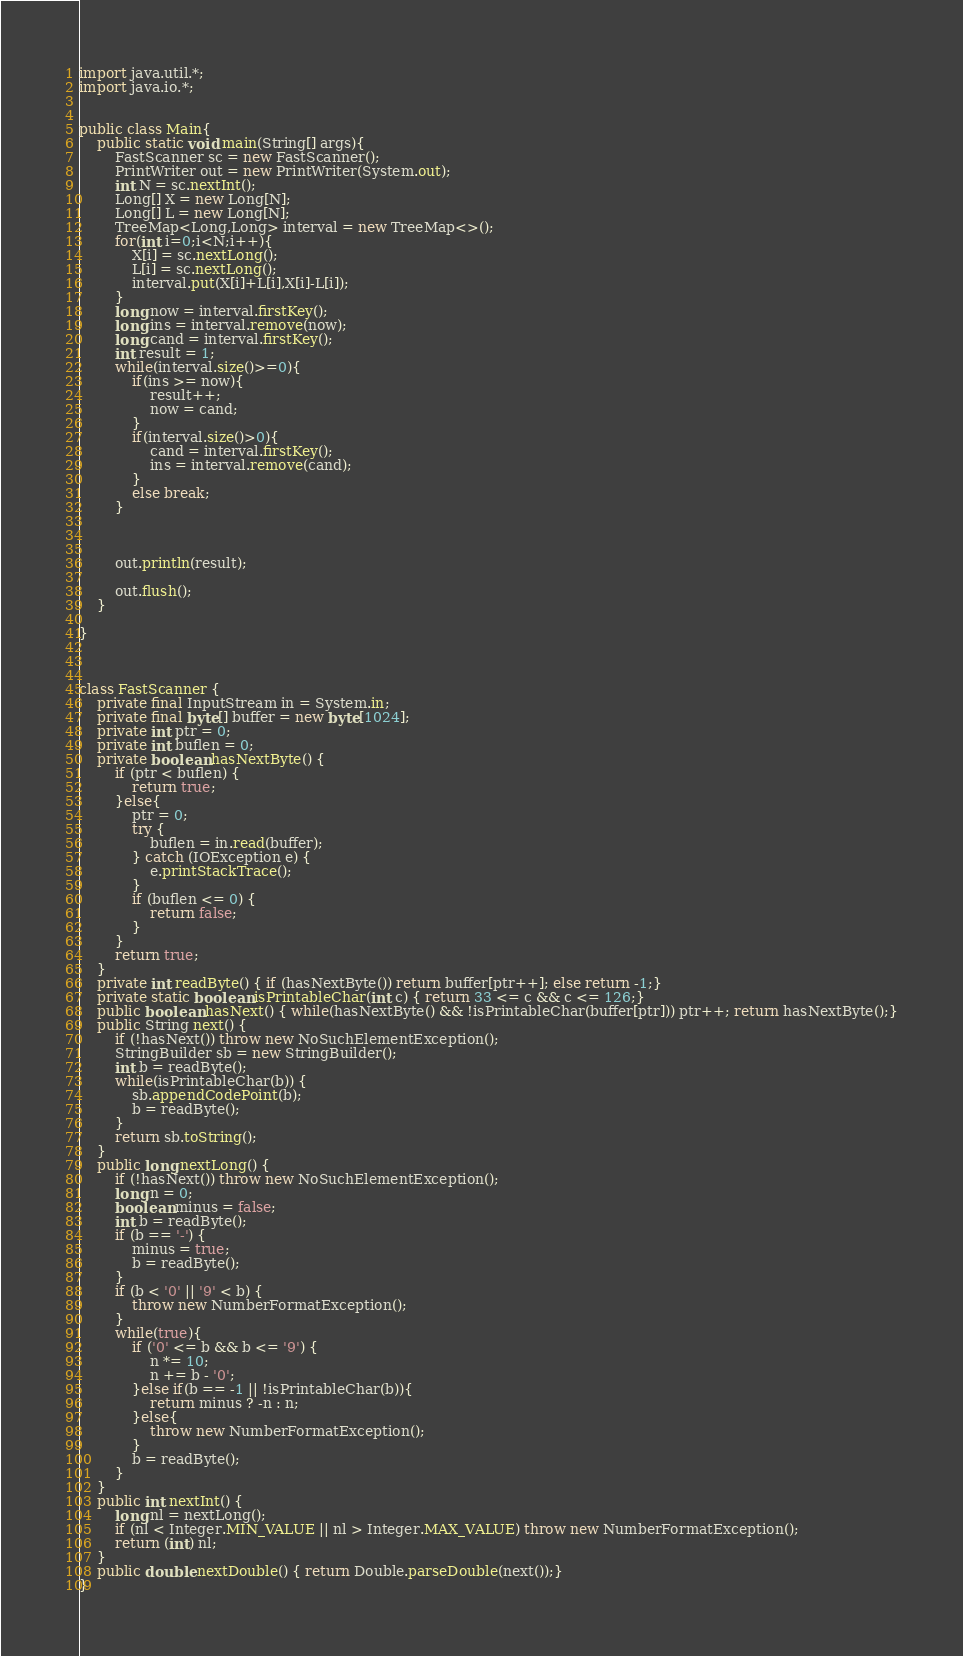<code> <loc_0><loc_0><loc_500><loc_500><_Java_>import java.util.*;
import java.io.*;


public class Main{
    public static void main(String[] args){
        FastScanner sc = new FastScanner();
        PrintWriter out = new PrintWriter(System.out);
        int N = sc.nextInt();
        Long[] X = new Long[N];
        Long[] L = new Long[N];
        TreeMap<Long,Long> interval = new TreeMap<>();
        for(int i=0;i<N;i++){
            X[i] = sc.nextLong();
            L[i] = sc.nextLong();
            interval.put(X[i]+L[i],X[i]-L[i]);
        }
        long now = interval.firstKey();
        long ins = interval.remove(now);
        long cand = interval.firstKey();
        int result = 1;
        while(interval.size()>=0){
            if(ins >= now){
                result++;
                now = cand;
            }
            if(interval.size()>0){
                cand = interval.firstKey();
                ins = interval.remove(cand);
            }
            else break;
        }



        out.println(result);

        out.flush();
    }
        
}



class FastScanner {
    private final InputStream in = System.in;
    private final byte[] buffer = new byte[1024];
    private int ptr = 0;
    private int buflen = 0;
    private boolean hasNextByte() {
        if (ptr < buflen) {
            return true;
        }else{
            ptr = 0;
            try {
                buflen = in.read(buffer);
            } catch (IOException e) {
                e.printStackTrace();
            }
            if (buflen <= 0) {
                return false;
            }
        }
        return true;
    }
    private int readByte() { if (hasNextByte()) return buffer[ptr++]; else return -1;}
    private static boolean isPrintableChar(int c) { return 33 <= c && c <= 126;}
    public boolean hasNext() { while(hasNextByte() && !isPrintableChar(buffer[ptr])) ptr++; return hasNextByte();}
    public String next() {
        if (!hasNext()) throw new NoSuchElementException();
        StringBuilder sb = new StringBuilder();
        int b = readByte();
        while(isPrintableChar(b)) {
            sb.appendCodePoint(b);
            b = readByte();
        }
        return sb.toString();
    }
    public long nextLong() {
        if (!hasNext()) throw new NoSuchElementException();
        long n = 0;
        boolean minus = false;
        int b = readByte();
        if (b == '-') {
            minus = true;
            b = readByte();
        }
        if (b < '0' || '9' < b) {
            throw new NumberFormatException();
        }
        while(true){
            if ('0' <= b && b <= '9') {
                n *= 10;
                n += b - '0';
            }else if(b == -1 || !isPrintableChar(b)){
                return minus ? -n : n;
            }else{
                throw new NumberFormatException();
            }
            b = readByte();
        }
    }
    public int nextInt() {
        long nl = nextLong();
        if (nl < Integer.MIN_VALUE || nl > Integer.MAX_VALUE) throw new NumberFormatException();
        return (int) nl;
    }
    public double nextDouble() { return Double.parseDouble(next());}
}</code> 